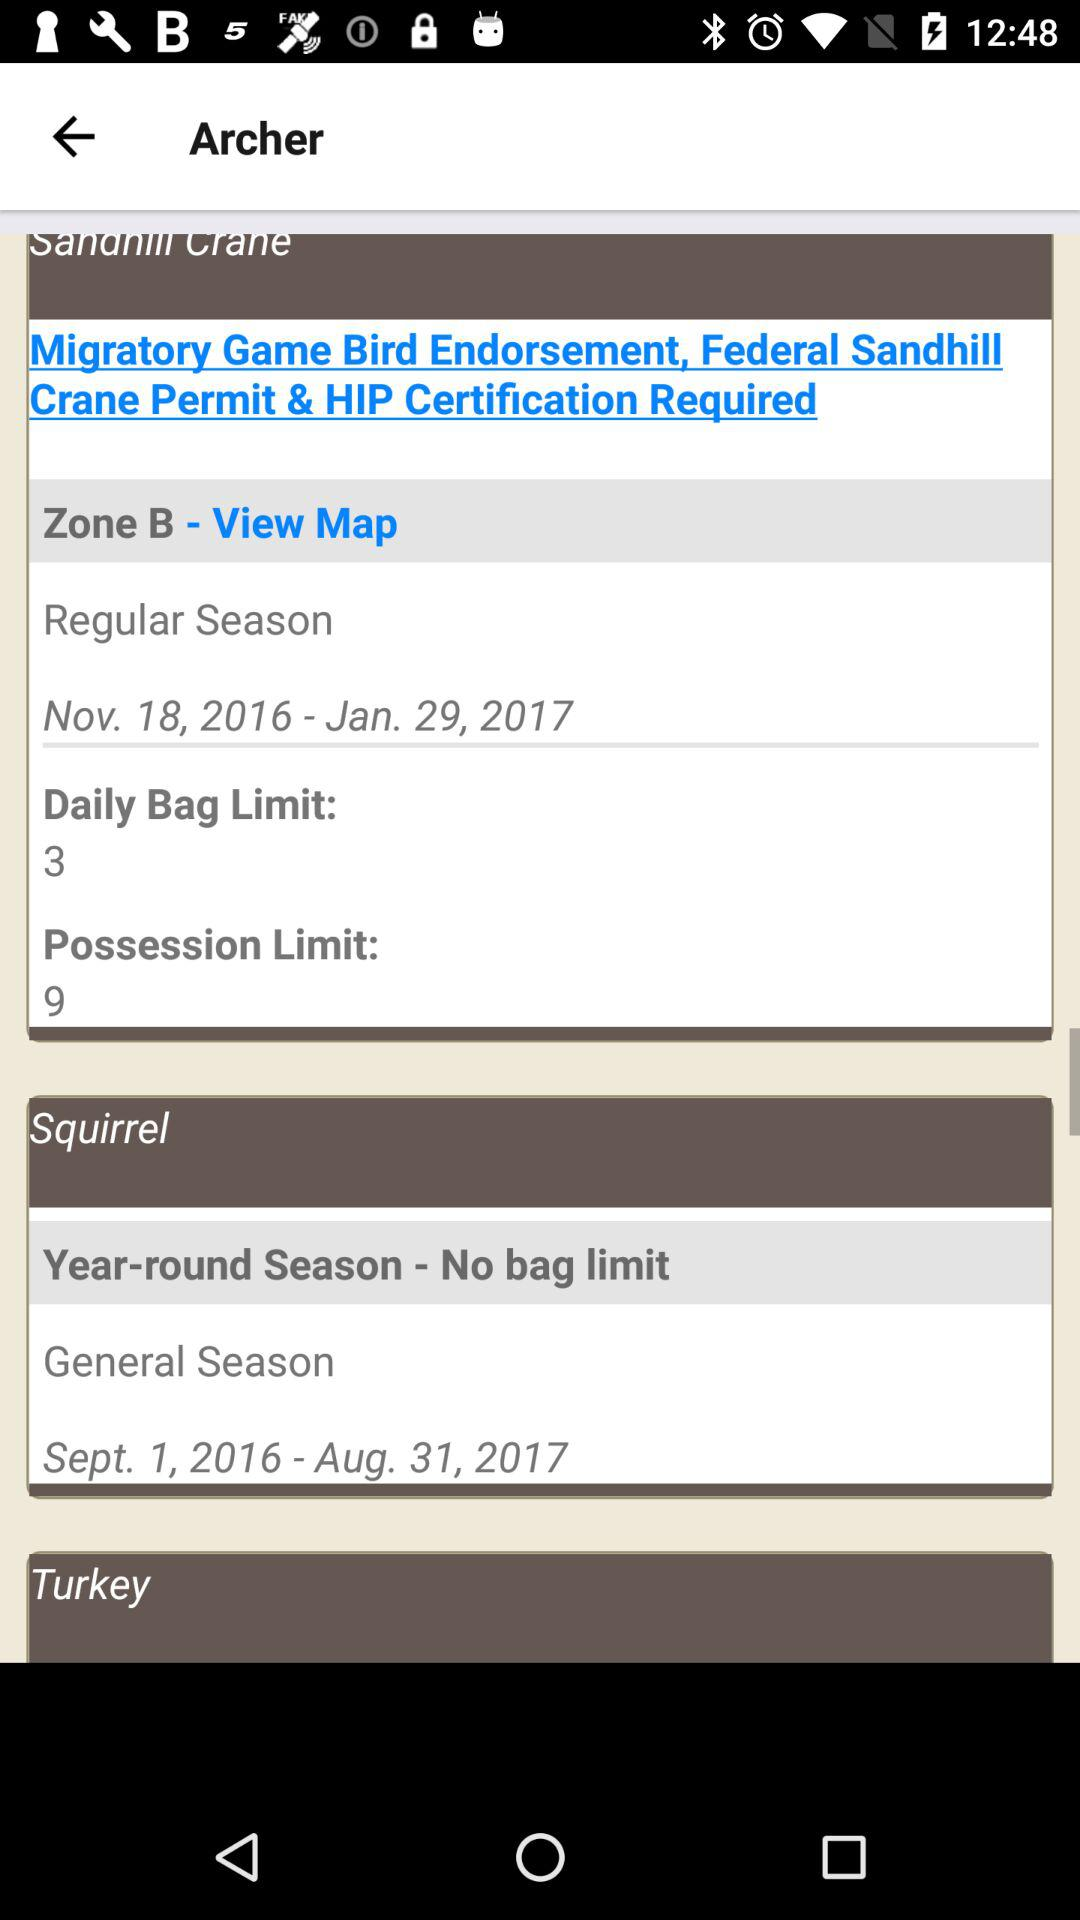What is the mentioned zone? The mentioned zone is "Zone B". 